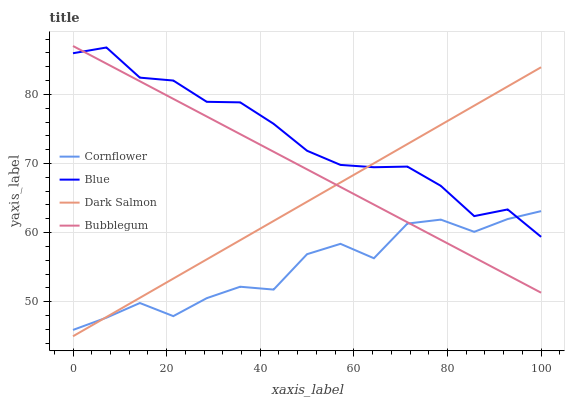Does Cornflower have the minimum area under the curve?
Answer yes or no. Yes. Does Blue have the maximum area under the curve?
Answer yes or no. Yes. Does Dark Salmon have the minimum area under the curve?
Answer yes or no. No. Does Dark Salmon have the maximum area under the curve?
Answer yes or no. No. Is Bubblegum the smoothest?
Answer yes or no. Yes. Is Cornflower the roughest?
Answer yes or no. Yes. Is Dark Salmon the smoothest?
Answer yes or no. No. Is Dark Salmon the roughest?
Answer yes or no. No. Does Dark Salmon have the lowest value?
Answer yes or no. Yes. Does Cornflower have the lowest value?
Answer yes or no. No. Does Bubblegum have the highest value?
Answer yes or no. Yes. Does Dark Salmon have the highest value?
Answer yes or no. No. Does Blue intersect Cornflower?
Answer yes or no. Yes. Is Blue less than Cornflower?
Answer yes or no. No. Is Blue greater than Cornflower?
Answer yes or no. No. 